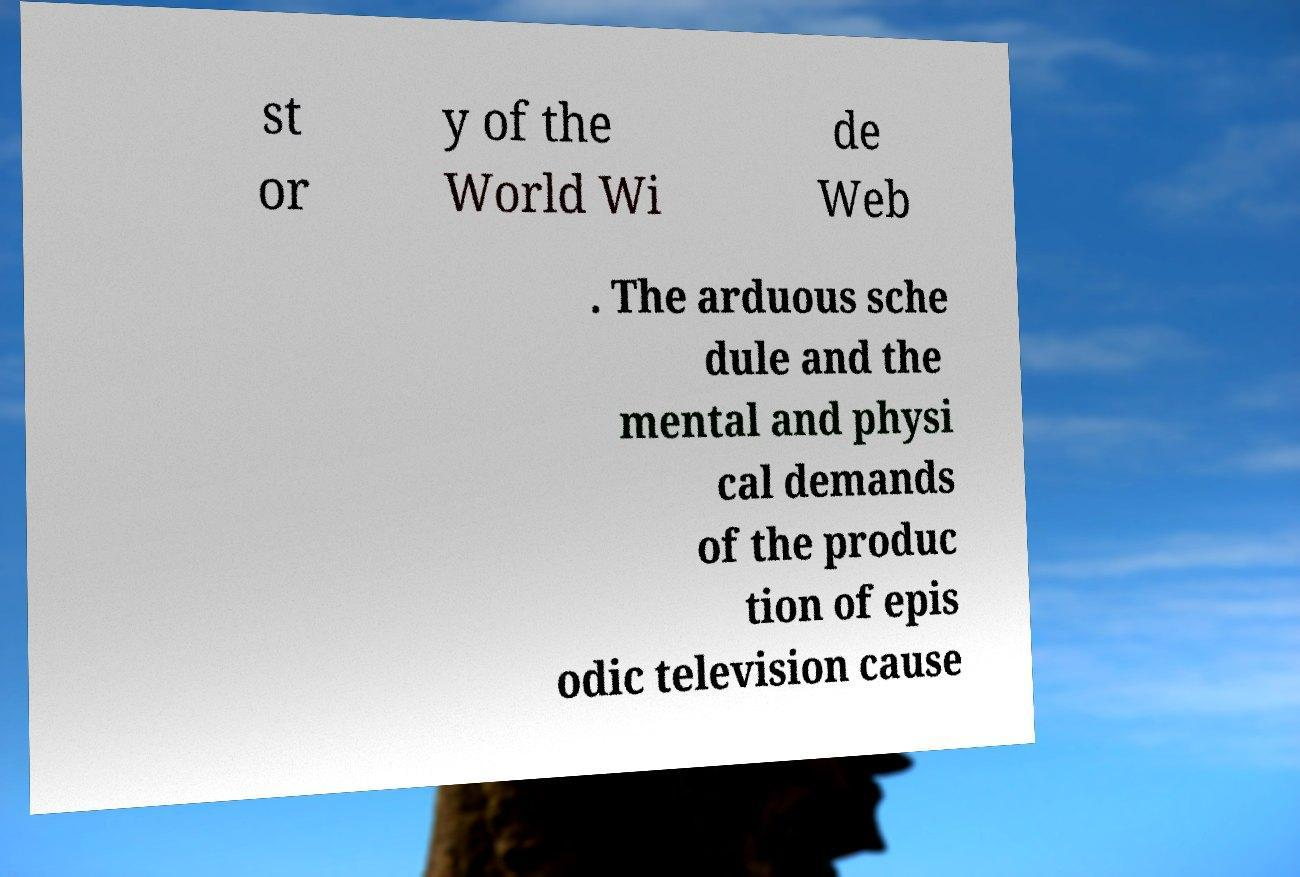I need the written content from this picture converted into text. Can you do that? st or y of the World Wi de Web . The arduous sche dule and the mental and physi cal demands of the produc tion of epis odic television cause 